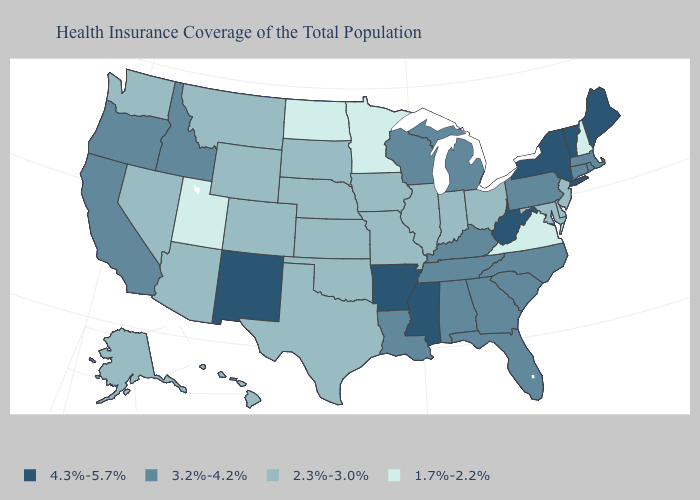Among the states that border Vermont , which have the lowest value?
Concise answer only. New Hampshire. Among the states that border South Dakota , does Wyoming have the highest value?
Answer briefly. Yes. What is the value of Minnesota?
Answer briefly. 1.7%-2.2%. Name the states that have a value in the range 4.3%-5.7%?
Quick response, please. Arkansas, Maine, Mississippi, New Mexico, New York, Vermont, West Virginia. Does North Dakota have the highest value in the MidWest?
Be succinct. No. Name the states that have a value in the range 1.7%-2.2%?
Short answer required. Minnesota, New Hampshire, North Dakota, Utah, Virginia. What is the value of Washington?
Short answer required. 2.3%-3.0%. Name the states that have a value in the range 4.3%-5.7%?
Short answer required. Arkansas, Maine, Mississippi, New Mexico, New York, Vermont, West Virginia. Does Delaware have the lowest value in the USA?
Concise answer only. No. Does Oklahoma have the lowest value in the South?
Concise answer only. No. Name the states that have a value in the range 3.2%-4.2%?
Be succinct. Alabama, California, Connecticut, Florida, Georgia, Idaho, Kentucky, Louisiana, Massachusetts, Michigan, North Carolina, Oregon, Pennsylvania, Rhode Island, South Carolina, Tennessee, Wisconsin. Among the states that border Pennsylvania , does New York have the highest value?
Keep it brief. Yes. Which states have the highest value in the USA?
Answer briefly. Arkansas, Maine, Mississippi, New Mexico, New York, Vermont, West Virginia. Name the states that have a value in the range 2.3%-3.0%?
Keep it brief. Alaska, Arizona, Colorado, Delaware, Hawaii, Illinois, Indiana, Iowa, Kansas, Maryland, Missouri, Montana, Nebraska, Nevada, New Jersey, Ohio, Oklahoma, South Dakota, Texas, Washington, Wyoming. What is the lowest value in states that border South Dakota?
Quick response, please. 1.7%-2.2%. 